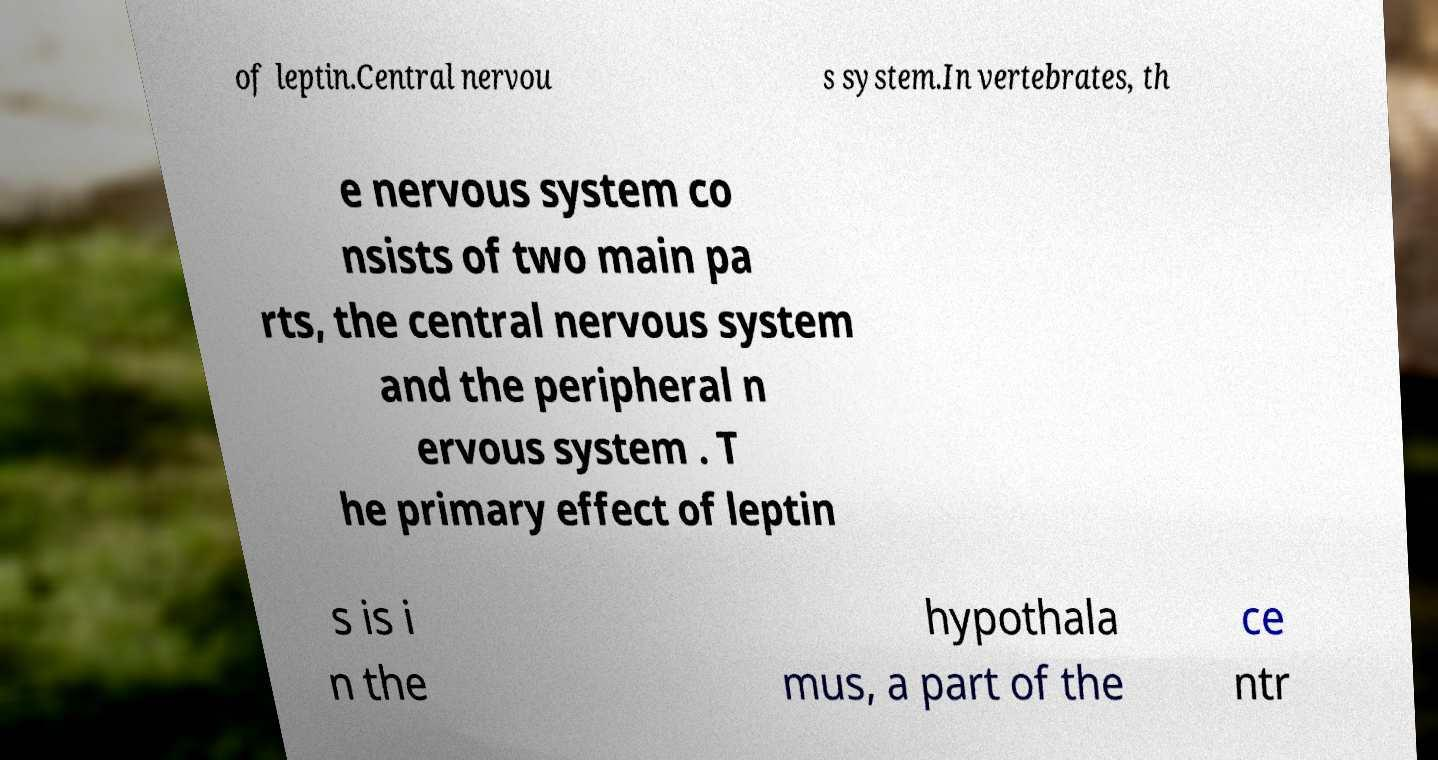I need the written content from this picture converted into text. Can you do that? of leptin.Central nervou s system.In vertebrates, th e nervous system co nsists of two main pa rts, the central nervous system and the peripheral n ervous system . T he primary effect of leptin s is i n the hypothala mus, a part of the ce ntr 